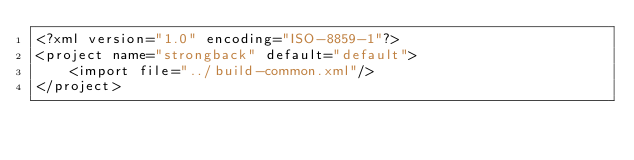<code> <loc_0><loc_0><loc_500><loc_500><_XML_><?xml version="1.0" encoding="ISO-8859-1"?>
<project name="strongback" default="default">
    <import file="../build-common.xml"/>
</project></code> 